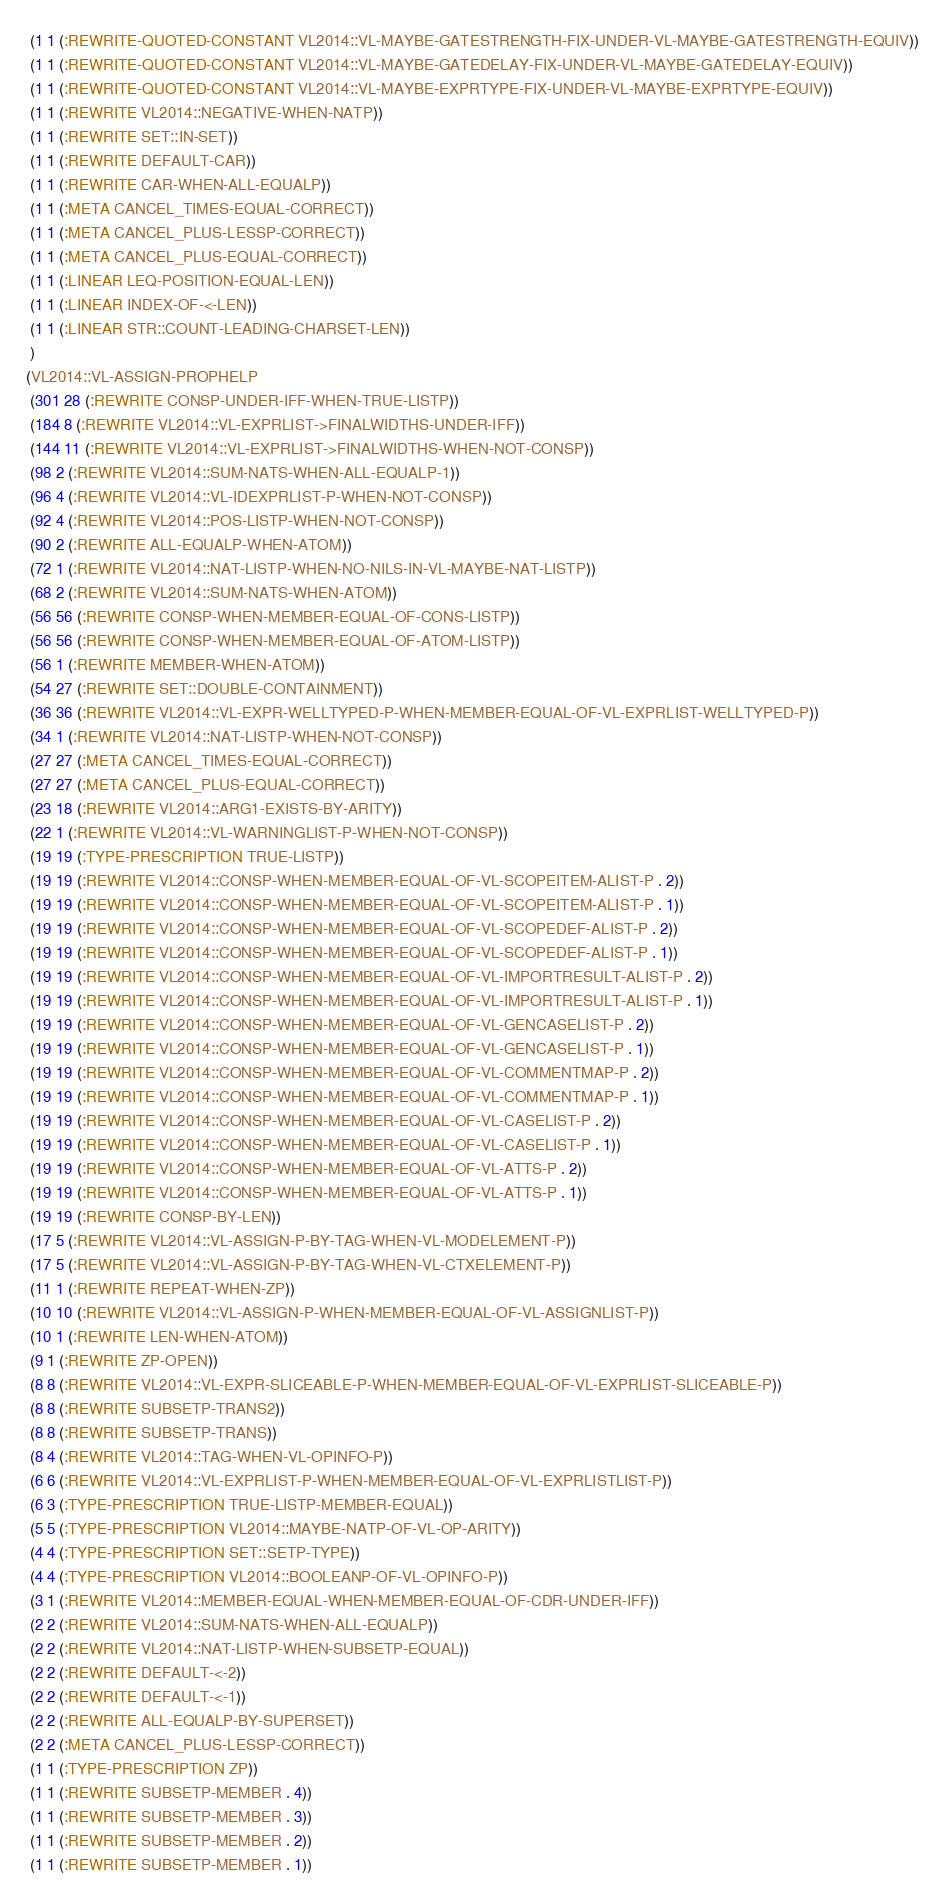Convert code to text. <code><loc_0><loc_0><loc_500><loc_500><_Lisp_> (1 1 (:REWRITE-QUOTED-CONSTANT VL2014::VL-MAYBE-GATESTRENGTH-FIX-UNDER-VL-MAYBE-GATESTRENGTH-EQUIV))
 (1 1 (:REWRITE-QUOTED-CONSTANT VL2014::VL-MAYBE-GATEDELAY-FIX-UNDER-VL-MAYBE-GATEDELAY-EQUIV))
 (1 1 (:REWRITE-QUOTED-CONSTANT VL2014::VL-MAYBE-EXPRTYPE-FIX-UNDER-VL-MAYBE-EXPRTYPE-EQUIV))
 (1 1 (:REWRITE VL2014::NEGATIVE-WHEN-NATP))
 (1 1 (:REWRITE SET::IN-SET))
 (1 1 (:REWRITE DEFAULT-CAR))
 (1 1 (:REWRITE CAR-WHEN-ALL-EQUALP))
 (1 1 (:META CANCEL_TIMES-EQUAL-CORRECT))
 (1 1 (:META CANCEL_PLUS-LESSP-CORRECT))
 (1 1 (:META CANCEL_PLUS-EQUAL-CORRECT))
 (1 1 (:LINEAR LEQ-POSITION-EQUAL-LEN))
 (1 1 (:LINEAR INDEX-OF-<-LEN))
 (1 1 (:LINEAR STR::COUNT-LEADING-CHARSET-LEN))
 )
(VL2014::VL-ASSIGN-PROPHELP
 (301 28 (:REWRITE CONSP-UNDER-IFF-WHEN-TRUE-LISTP))
 (184 8 (:REWRITE VL2014::VL-EXPRLIST->FINALWIDTHS-UNDER-IFF))
 (144 11 (:REWRITE VL2014::VL-EXPRLIST->FINALWIDTHS-WHEN-NOT-CONSP))
 (98 2 (:REWRITE VL2014::SUM-NATS-WHEN-ALL-EQUALP-1))
 (96 4 (:REWRITE VL2014::VL-IDEXPRLIST-P-WHEN-NOT-CONSP))
 (92 4 (:REWRITE VL2014::POS-LISTP-WHEN-NOT-CONSP))
 (90 2 (:REWRITE ALL-EQUALP-WHEN-ATOM))
 (72 1 (:REWRITE VL2014::NAT-LISTP-WHEN-NO-NILS-IN-VL-MAYBE-NAT-LISTP))
 (68 2 (:REWRITE VL2014::SUM-NATS-WHEN-ATOM))
 (56 56 (:REWRITE CONSP-WHEN-MEMBER-EQUAL-OF-CONS-LISTP))
 (56 56 (:REWRITE CONSP-WHEN-MEMBER-EQUAL-OF-ATOM-LISTP))
 (56 1 (:REWRITE MEMBER-WHEN-ATOM))
 (54 27 (:REWRITE SET::DOUBLE-CONTAINMENT))
 (36 36 (:REWRITE VL2014::VL-EXPR-WELLTYPED-P-WHEN-MEMBER-EQUAL-OF-VL-EXPRLIST-WELLTYPED-P))
 (34 1 (:REWRITE VL2014::NAT-LISTP-WHEN-NOT-CONSP))
 (27 27 (:META CANCEL_TIMES-EQUAL-CORRECT))
 (27 27 (:META CANCEL_PLUS-EQUAL-CORRECT))
 (23 18 (:REWRITE VL2014::ARG1-EXISTS-BY-ARITY))
 (22 1 (:REWRITE VL2014::VL-WARNINGLIST-P-WHEN-NOT-CONSP))
 (19 19 (:TYPE-PRESCRIPTION TRUE-LISTP))
 (19 19 (:REWRITE VL2014::CONSP-WHEN-MEMBER-EQUAL-OF-VL-SCOPEITEM-ALIST-P . 2))
 (19 19 (:REWRITE VL2014::CONSP-WHEN-MEMBER-EQUAL-OF-VL-SCOPEITEM-ALIST-P . 1))
 (19 19 (:REWRITE VL2014::CONSP-WHEN-MEMBER-EQUAL-OF-VL-SCOPEDEF-ALIST-P . 2))
 (19 19 (:REWRITE VL2014::CONSP-WHEN-MEMBER-EQUAL-OF-VL-SCOPEDEF-ALIST-P . 1))
 (19 19 (:REWRITE VL2014::CONSP-WHEN-MEMBER-EQUAL-OF-VL-IMPORTRESULT-ALIST-P . 2))
 (19 19 (:REWRITE VL2014::CONSP-WHEN-MEMBER-EQUAL-OF-VL-IMPORTRESULT-ALIST-P . 1))
 (19 19 (:REWRITE VL2014::CONSP-WHEN-MEMBER-EQUAL-OF-VL-GENCASELIST-P . 2))
 (19 19 (:REWRITE VL2014::CONSP-WHEN-MEMBER-EQUAL-OF-VL-GENCASELIST-P . 1))
 (19 19 (:REWRITE VL2014::CONSP-WHEN-MEMBER-EQUAL-OF-VL-COMMENTMAP-P . 2))
 (19 19 (:REWRITE VL2014::CONSP-WHEN-MEMBER-EQUAL-OF-VL-COMMENTMAP-P . 1))
 (19 19 (:REWRITE VL2014::CONSP-WHEN-MEMBER-EQUAL-OF-VL-CASELIST-P . 2))
 (19 19 (:REWRITE VL2014::CONSP-WHEN-MEMBER-EQUAL-OF-VL-CASELIST-P . 1))
 (19 19 (:REWRITE VL2014::CONSP-WHEN-MEMBER-EQUAL-OF-VL-ATTS-P . 2))
 (19 19 (:REWRITE VL2014::CONSP-WHEN-MEMBER-EQUAL-OF-VL-ATTS-P . 1))
 (19 19 (:REWRITE CONSP-BY-LEN))
 (17 5 (:REWRITE VL2014::VL-ASSIGN-P-BY-TAG-WHEN-VL-MODELEMENT-P))
 (17 5 (:REWRITE VL2014::VL-ASSIGN-P-BY-TAG-WHEN-VL-CTXELEMENT-P))
 (11 1 (:REWRITE REPEAT-WHEN-ZP))
 (10 10 (:REWRITE VL2014::VL-ASSIGN-P-WHEN-MEMBER-EQUAL-OF-VL-ASSIGNLIST-P))
 (10 1 (:REWRITE LEN-WHEN-ATOM))
 (9 1 (:REWRITE ZP-OPEN))
 (8 8 (:REWRITE VL2014::VL-EXPR-SLICEABLE-P-WHEN-MEMBER-EQUAL-OF-VL-EXPRLIST-SLICEABLE-P))
 (8 8 (:REWRITE SUBSETP-TRANS2))
 (8 8 (:REWRITE SUBSETP-TRANS))
 (8 4 (:REWRITE VL2014::TAG-WHEN-VL-OPINFO-P))
 (6 6 (:REWRITE VL2014::VL-EXPRLIST-P-WHEN-MEMBER-EQUAL-OF-VL-EXPRLISTLIST-P))
 (6 3 (:TYPE-PRESCRIPTION TRUE-LISTP-MEMBER-EQUAL))
 (5 5 (:TYPE-PRESCRIPTION VL2014::MAYBE-NATP-OF-VL-OP-ARITY))
 (4 4 (:TYPE-PRESCRIPTION SET::SETP-TYPE))
 (4 4 (:TYPE-PRESCRIPTION VL2014::BOOLEANP-OF-VL-OPINFO-P))
 (3 1 (:REWRITE VL2014::MEMBER-EQUAL-WHEN-MEMBER-EQUAL-OF-CDR-UNDER-IFF))
 (2 2 (:REWRITE VL2014::SUM-NATS-WHEN-ALL-EQUALP))
 (2 2 (:REWRITE VL2014::NAT-LISTP-WHEN-SUBSETP-EQUAL))
 (2 2 (:REWRITE DEFAULT-<-2))
 (2 2 (:REWRITE DEFAULT-<-1))
 (2 2 (:REWRITE ALL-EQUALP-BY-SUPERSET))
 (2 2 (:META CANCEL_PLUS-LESSP-CORRECT))
 (1 1 (:TYPE-PRESCRIPTION ZP))
 (1 1 (:REWRITE SUBSETP-MEMBER . 4))
 (1 1 (:REWRITE SUBSETP-MEMBER . 3))
 (1 1 (:REWRITE SUBSETP-MEMBER . 2))
 (1 1 (:REWRITE SUBSETP-MEMBER . 1))</code> 